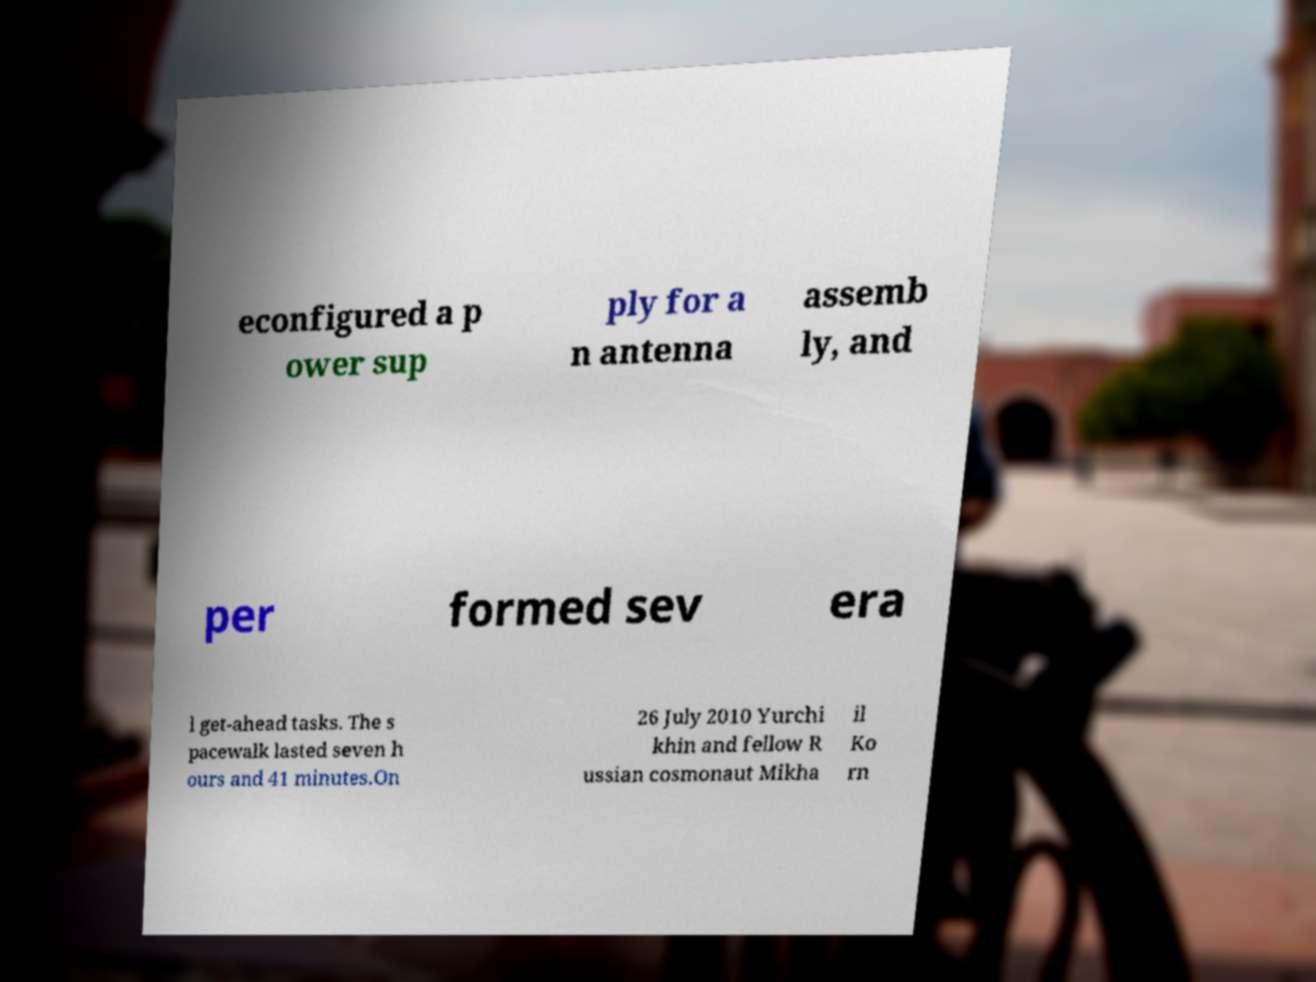Please read and relay the text visible in this image. What does it say? econfigured a p ower sup ply for a n antenna assemb ly, and per formed sev era l get-ahead tasks. The s pacewalk lasted seven h ours and 41 minutes.On 26 July 2010 Yurchi khin and fellow R ussian cosmonaut Mikha il Ko rn 